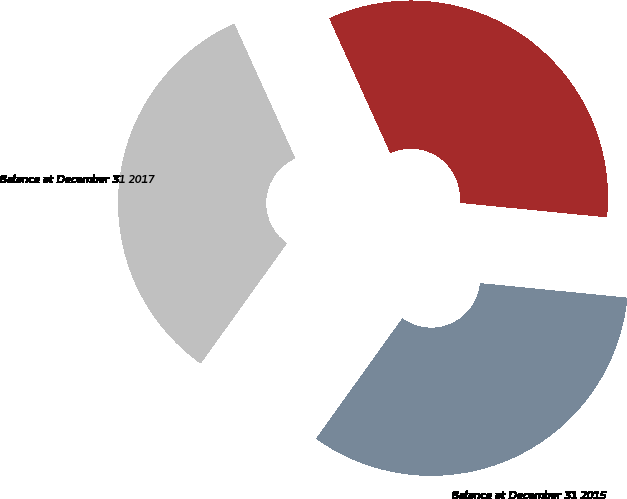<chart> <loc_0><loc_0><loc_500><loc_500><pie_chart><fcel>Balance at December 31 2015<fcel>Balance at December 31 2016<fcel>Balance at December 31 2017<nl><fcel>33.33%<fcel>33.33%<fcel>33.33%<nl></chart> 